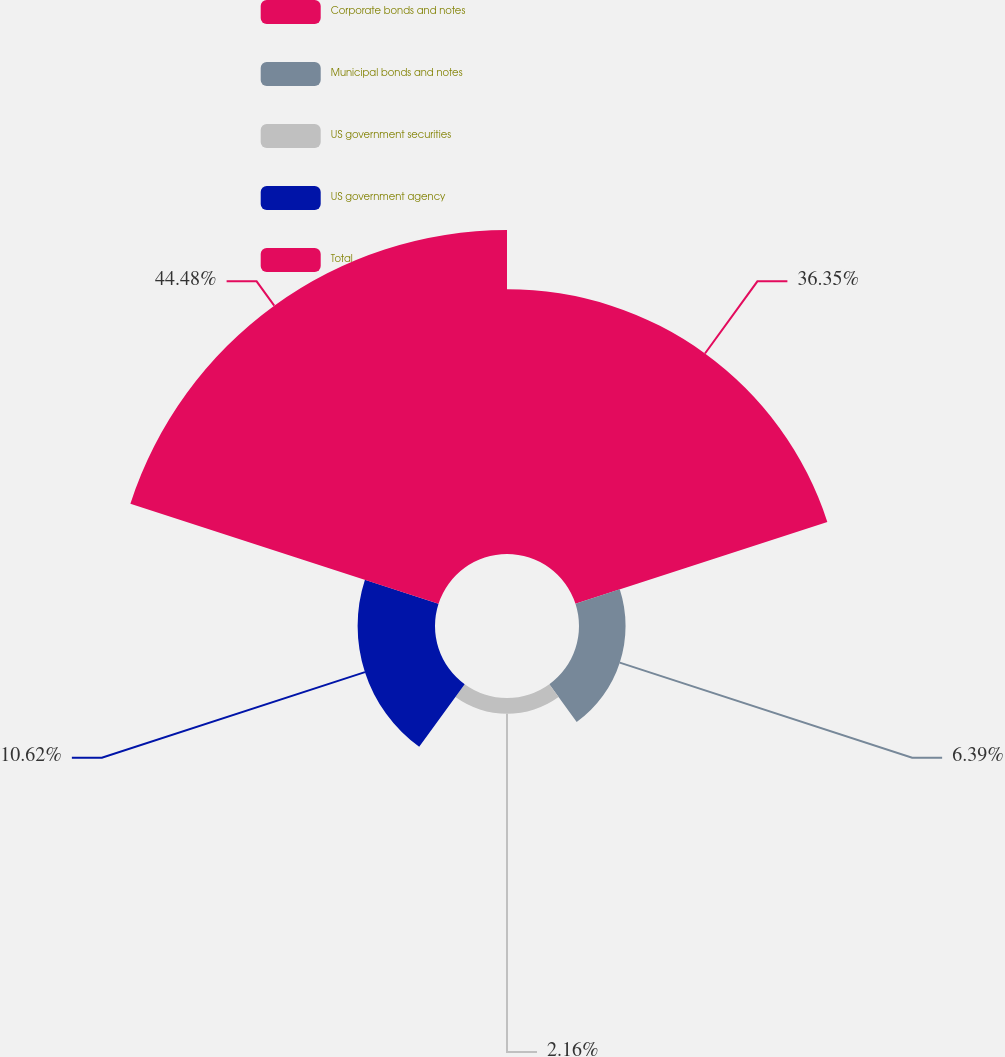<chart> <loc_0><loc_0><loc_500><loc_500><pie_chart><fcel>Corporate bonds and notes<fcel>Municipal bonds and notes<fcel>US government securities<fcel>US government agency<fcel>Total<nl><fcel>36.35%<fcel>6.39%<fcel>2.16%<fcel>10.62%<fcel>44.47%<nl></chart> 